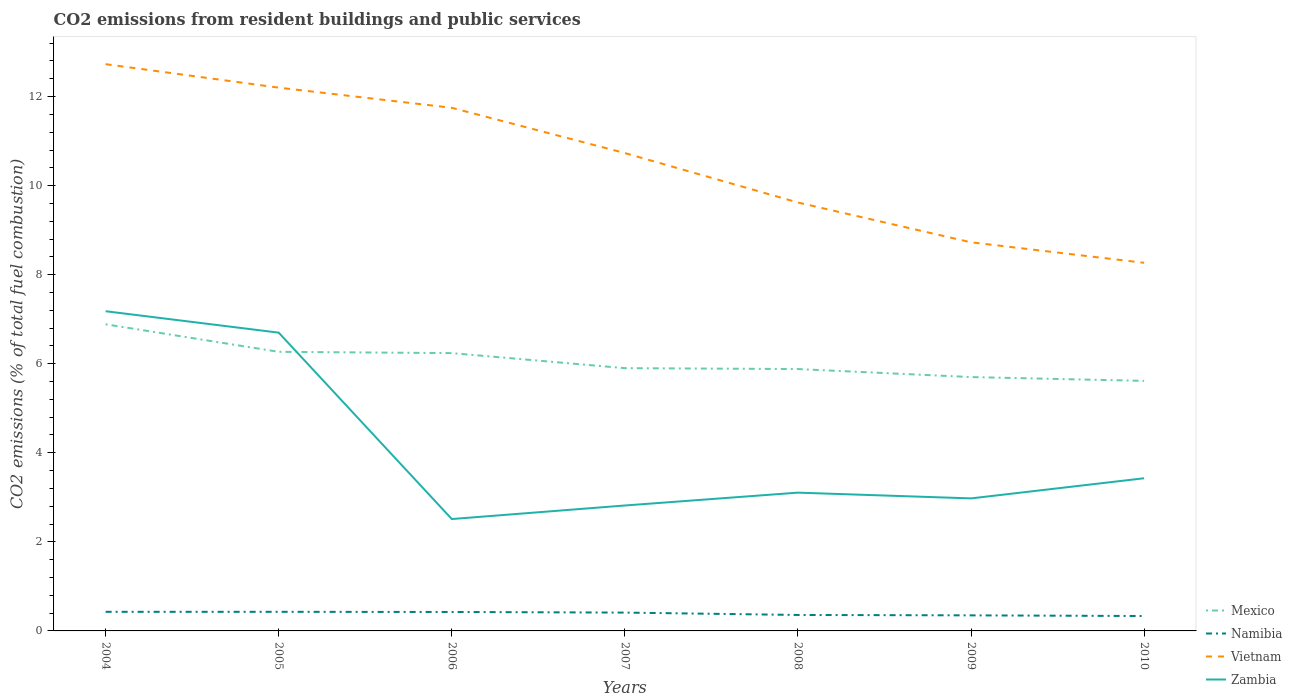Is the number of lines equal to the number of legend labels?
Provide a short and direct response. Yes. Across all years, what is the maximum total CO2 emitted in Zambia?
Offer a terse response. 2.51. In which year was the total CO2 emitted in Zambia maximum?
Provide a short and direct response. 2006. What is the total total CO2 emitted in Namibia in the graph?
Your answer should be compact. 0.05. What is the difference between the highest and the second highest total CO2 emitted in Namibia?
Provide a short and direct response. 0.09. Is the total CO2 emitted in Mexico strictly greater than the total CO2 emitted in Namibia over the years?
Your answer should be compact. No. How many years are there in the graph?
Provide a short and direct response. 7. What is the difference between two consecutive major ticks on the Y-axis?
Your answer should be compact. 2. Are the values on the major ticks of Y-axis written in scientific E-notation?
Give a very brief answer. No. Does the graph contain any zero values?
Provide a short and direct response. No. Does the graph contain grids?
Your answer should be compact. No. Where does the legend appear in the graph?
Offer a very short reply. Bottom right. What is the title of the graph?
Provide a succinct answer. CO2 emissions from resident buildings and public services. What is the label or title of the Y-axis?
Offer a terse response. CO2 emissions (% of total fuel combustion). What is the CO2 emissions (% of total fuel combustion) in Mexico in 2004?
Ensure brevity in your answer.  6.89. What is the CO2 emissions (% of total fuel combustion) in Namibia in 2004?
Give a very brief answer. 0.43. What is the CO2 emissions (% of total fuel combustion) of Vietnam in 2004?
Provide a short and direct response. 12.73. What is the CO2 emissions (% of total fuel combustion) in Zambia in 2004?
Your answer should be very brief. 7.18. What is the CO2 emissions (% of total fuel combustion) of Mexico in 2005?
Your answer should be compact. 6.27. What is the CO2 emissions (% of total fuel combustion) in Namibia in 2005?
Ensure brevity in your answer.  0.43. What is the CO2 emissions (% of total fuel combustion) in Vietnam in 2005?
Your response must be concise. 12.2. What is the CO2 emissions (% of total fuel combustion) of Zambia in 2005?
Keep it short and to the point. 6.7. What is the CO2 emissions (% of total fuel combustion) of Mexico in 2006?
Your answer should be compact. 6.24. What is the CO2 emissions (% of total fuel combustion) of Namibia in 2006?
Give a very brief answer. 0.43. What is the CO2 emissions (% of total fuel combustion) in Vietnam in 2006?
Provide a succinct answer. 11.75. What is the CO2 emissions (% of total fuel combustion) of Zambia in 2006?
Offer a very short reply. 2.51. What is the CO2 emissions (% of total fuel combustion) in Mexico in 2007?
Your response must be concise. 5.9. What is the CO2 emissions (% of total fuel combustion) in Namibia in 2007?
Provide a short and direct response. 0.41. What is the CO2 emissions (% of total fuel combustion) in Vietnam in 2007?
Give a very brief answer. 10.73. What is the CO2 emissions (% of total fuel combustion) of Zambia in 2007?
Ensure brevity in your answer.  2.82. What is the CO2 emissions (% of total fuel combustion) in Mexico in 2008?
Provide a short and direct response. 5.88. What is the CO2 emissions (% of total fuel combustion) of Namibia in 2008?
Your answer should be compact. 0.36. What is the CO2 emissions (% of total fuel combustion) in Vietnam in 2008?
Keep it short and to the point. 9.62. What is the CO2 emissions (% of total fuel combustion) in Zambia in 2008?
Keep it short and to the point. 3.11. What is the CO2 emissions (% of total fuel combustion) in Mexico in 2009?
Give a very brief answer. 5.7. What is the CO2 emissions (% of total fuel combustion) in Namibia in 2009?
Provide a short and direct response. 0.35. What is the CO2 emissions (% of total fuel combustion) in Vietnam in 2009?
Ensure brevity in your answer.  8.73. What is the CO2 emissions (% of total fuel combustion) in Zambia in 2009?
Offer a terse response. 2.98. What is the CO2 emissions (% of total fuel combustion) in Mexico in 2010?
Provide a short and direct response. 5.62. What is the CO2 emissions (% of total fuel combustion) of Namibia in 2010?
Offer a very short reply. 0.33. What is the CO2 emissions (% of total fuel combustion) in Vietnam in 2010?
Your answer should be very brief. 8.27. What is the CO2 emissions (% of total fuel combustion) in Zambia in 2010?
Keep it short and to the point. 3.43. Across all years, what is the maximum CO2 emissions (% of total fuel combustion) of Mexico?
Your answer should be compact. 6.89. Across all years, what is the maximum CO2 emissions (% of total fuel combustion) of Namibia?
Give a very brief answer. 0.43. Across all years, what is the maximum CO2 emissions (% of total fuel combustion) of Vietnam?
Offer a terse response. 12.73. Across all years, what is the maximum CO2 emissions (% of total fuel combustion) of Zambia?
Offer a terse response. 7.18. Across all years, what is the minimum CO2 emissions (% of total fuel combustion) in Mexico?
Keep it short and to the point. 5.62. Across all years, what is the minimum CO2 emissions (% of total fuel combustion) of Namibia?
Make the answer very short. 0.33. Across all years, what is the minimum CO2 emissions (% of total fuel combustion) of Vietnam?
Provide a succinct answer. 8.27. Across all years, what is the minimum CO2 emissions (% of total fuel combustion) of Zambia?
Offer a very short reply. 2.51. What is the total CO2 emissions (% of total fuel combustion) of Mexico in the graph?
Offer a terse response. 42.49. What is the total CO2 emissions (% of total fuel combustion) of Namibia in the graph?
Provide a short and direct response. 2.74. What is the total CO2 emissions (% of total fuel combustion) in Vietnam in the graph?
Give a very brief answer. 74.02. What is the total CO2 emissions (% of total fuel combustion) in Zambia in the graph?
Your response must be concise. 28.72. What is the difference between the CO2 emissions (% of total fuel combustion) in Mexico in 2004 and that in 2005?
Your answer should be very brief. 0.62. What is the difference between the CO2 emissions (% of total fuel combustion) in Vietnam in 2004 and that in 2005?
Offer a terse response. 0.53. What is the difference between the CO2 emissions (% of total fuel combustion) in Zambia in 2004 and that in 2005?
Provide a short and direct response. 0.48. What is the difference between the CO2 emissions (% of total fuel combustion) in Mexico in 2004 and that in 2006?
Offer a terse response. 0.65. What is the difference between the CO2 emissions (% of total fuel combustion) of Namibia in 2004 and that in 2006?
Your answer should be compact. 0. What is the difference between the CO2 emissions (% of total fuel combustion) in Vietnam in 2004 and that in 2006?
Ensure brevity in your answer.  0.98. What is the difference between the CO2 emissions (% of total fuel combustion) of Zambia in 2004 and that in 2006?
Provide a short and direct response. 4.67. What is the difference between the CO2 emissions (% of total fuel combustion) of Mexico in 2004 and that in 2007?
Provide a succinct answer. 0.99. What is the difference between the CO2 emissions (% of total fuel combustion) in Namibia in 2004 and that in 2007?
Your response must be concise. 0.02. What is the difference between the CO2 emissions (% of total fuel combustion) in Vietnam in 2004 and that in 2007?
Your response must be concise. 2. What is the difference between the CO2 emissions (% of total fuel combustion) of Zambia in 2004 and that in 2007?
Make the answer very short. 4.36. What is the difference between the CO2 emissions (% of total fuel combustion) in Mexico in 2004 and that in 2008?
Provide a succinct answer. 1.01. What is the difference between the CO2 emissions (% of total fuel combustion) in Namibia in 2004 and that in 2008?
Ensure brevity in your answer.  0.07. What is the difference between the CO2 emissions (% of total fuel combustion) of Vietnam in 2004 and that in 2008?
Offer a very short reply. 3.11. What is the difference between the CO2 emissions (% of total fuel combustion) of Zambia in 2004 and that in 2008?
Make the answer very short. 4.07. What is the difference between the CO2 emissions (% of total fuel combustion) of Mexico in 2004 and that in 2009?
Ensure brevity in your answer.  1.19. What is the difference between the CO2 emissions (% of total fuel combustion) in Namibia in 2004 and that in 2009?
Provide a short and direct response. 0.08. What is the difference between the CO2 emissions (% of total fuel combustion) of Vietnam in 2004 and that in 2009?
Ensure brevity in your answer.  4. What is the difference between the CO2 emissions (% of total fuel combustion) of Zambia in 2004 and that in 2009?
Offer a very short reply. 4.2. What is the difference between the CO2 emissions (% of total fuel combustion) of Mexico in 2004 and that in 2010?
Offer a terse response. 1.27. What is the difference between the CO2 emissions (% of total fuel combustion) in Namibia in 2004 and that in 2010?
Provide a short and direct response. 0.09. What is the difference between the CO2 emissions (% of total fuel combustion) in Vietnam in 2004 and that in 2010?
Your response must be concise. 4.46. What is the difference between the CO2 emissions (% of total fuel combustion) of Zambia in 2004 and that in 2010?
Give a very brief answer. 3.75. What is the difference between the CO2 emissions (% of total fuel combustion) in Mexico in 2005 and that in 2006?
Provide a succinct answer. 0.03. What is the difference between the CO2 emissions (% of total fuel combustion) of Namibia in 2005 and that in 2006?
Ensure brevity in your answer.  0. What is the difference between the CO2 emissions (% of total fuel combustion) of Vietnam in 2005 and that in 2006?
Keep it short and to the point. 0.45. What is the difference between the CO2 emissions (% of total fuel combustion) in Zambia in 2005 and that in 2006?
Offer a very short reply. 4.19. What is the difference between the CO2 emissions (% of total fuel combustion) of Mexico in 2005 and that in 2007?
Your response must be concise. 0.37. What is the difference between the CO2 emissions (% of total fuel combustion) in Namibia in 2005 and that in 2007?
Provide a short and direct response. 0.02. What is the difference between the CO2 emissions (% of total fuel combustion) in Vietnam in 2005 and that in 2007?
Provide a succinct answer. 1.47. What is the difference between the CO2 emissions (% of total fuel combustion) in Zambia in 2005 and that in 2007?
Offer a terse response. 3.88. What is the difference between the CO2 emissions (% of total fuel combustion) of Mexico in 2005 and that in 2008?
Your response must be concise. 0.39. What is the difference between the CO2 emissions (% of total fuel combustion) in Namibia in 2005 and that in 2008?
Provide a short and direct response. 0.07. What is the difference between the CO2 emissions (% of total fuel combustion) in Vietnam in 2005 and that in 2008?
Ensure brevity in your answer.  2.58. What is the difference between the CO2 emissions (% of total fuel combustion) of Zambia in 2005 and that in 2008?
Provide a short and direct response. 3.59. What is the difference between the CO2 emissions (% of total fuel combustion) of Mexico in 2005 and that in 2009?
Your answer should be compact. 0.57. What is the difference between the CO2 emissions (% of total fuel combustion) of Namibia in 2005 and that in 2009?
Your answer should be compact. 0.08. What is the difference between the CO2 emissions (% of total fuel combustion) in Vietnam in 2005 and that in 2009?
Your response must be concise. 3.47. What is the difference between the CO2 emissions (% of total fuel combustion) of Zambia in 2005 and that in 2009?
Offer a very short reply. 3.72. What is the difference between the CO2 emissions (% of total fuel combustion) in Mexico in 2005 and that in 2010?
Give a very brief answer. 0.65. What is the difference between the CO2 emissions (% of total fuel combustion) in Namibia in 2005 and that in 2010?
Offer a very short reply. 0.09. What is the difference between the CO2 emissions (% of total fuel combustion) in Vietnam in 2005 and that in 2010?
Keep it short and to the point. 3.93. What is the difference between the CO2 emissions (% of total fuel combustion) in Zambia in 2005 and that in 2010?
Ensure brevity in your answer.  3.27. What is the difference between the CO2 emissions (% of total fuel combustion) in Mexico in 2006 and that in 2007?
Provide a short and direct response. 0.34. What is the difference between the CO2 emissions (% of total fuel combustion) in Namibia in 2006 and that in 2007?
Keep it short and to the point. 0.01. What is the difference between the CO2 emissions (% of total fuel combustion) in Vietnam in 2006 and that in 2007?
Offer a terse response. 1.02. What is the difference between the CO2 emissions (% of total fuel combustion) of Zambia in 2006 and that in 2007?
Keep it short and to the point. -0.3. What is the difference between the CO2 emissions (% of total fuel combustion) of Mexico in 2006 and that in 2008?
Your answer should be very brief. 0.36. What is the difference between the CO2 emissions (% of total fuel combustion) of Namibia in 2006 and that in 2008?
Your response must be concise. 0.07. What is the difference between the CO2 emissions (% of total fuel combustion) in Vietnam in 2006 and that in 2008?
Your response must be concise. 2.13. What is the difference between the CO2 emissions (% of total fuel combustion) of Zambia in 2006 and that in 2008?
Your answer should be very brief. -0.59. What is the difference between the CO2 emissions (% of total fuel combustion) of Mexico in 2006 and that in 2009?
Offer a very short reply. 0.54. What is the difference between the CO2 emissions (% of total fuel combustion) of Namibia in 2006 and that in 2009?
Make the answer very short. 0.08. What is the difference between the CO2 emissions (% of total fuel combustion) of Vietnam in 2006 and that in 2009?
Offer a terse response. 3.02. What is the difference between the CO2 emissions (% of total fuel combustion) in Zambia in 2006 and that in 2009?
Ensure brevity in your answer.  -0.46. What is the difference between the CO2 emissions (% of total fuel combustion) in Mexico in 2006 and that in 2010?
Offer a very short reply. 0.62. What is the difference between the CO2 emissions (% of total fuel combustion) of Namibia in 2006 and that in 2010?
Provide a short and direct response. 0.09. What is the difference between the CO2 emissions (% of total fuel combustion) in Vietnam in 2006 and that in 2010?
Offer a terse response. 3.48. What is the difference between the CO2 emissions (% of total fuel combustion) in Zambia in 2006 and that in 2010?
Provide a short and direct response. -0.92. What is the difference between the CO2 emissions (% of total fuel combustion) of Mexico in 2007 and that in 2008?
Provide a succinct answer. 0.02. What is the difference between the CO2 emissions (% of total fuel combustion) of Namibia in 2007 and that in 2008?
Give a very brief answer. 0.05. What is the difference between the CO2 emissions (% of total fuel combustion) in Vietnam in 2007 and that in 2008?
Your response must be concise. 1.11. What is the difference between the CO2 emissions (% of total fuel combustion) in Zambia in 2007 and that in 2008?
Provide a succinct answer. -0.29. What is the difference between the CO2 emissions (% of total fuel combustion) in Mexico in 2007 and that in 2009?
Offer a very short reply. 0.2. What is the difference between the CO2 emissions (% of total fuel combustion) in Namibia in 2007 and that in 2009?
Provide a short and direct response. 0.06. What is the difference between the CO2 emissions (% of total fuel combustion) of Vietnam in 2007 and that in 2009?
Ensure brevity in your answer.  2. What is the difference between the CO2 emissions (% of total fuel combustion) of Zambia in 2007 and that in 2009?
Provide a succinct answer. -0.16. What is the difference between the CO2 emissions (% of total fuel combustion) of Mexico in 2007 and that in 2010?
Offer a terse response. 0.29. What is the difference between the CO2 emissions (% of total fuel combustion) in Namibia in 2007 and that in 2010?
Your answer should be very brief. 0.08. What is the difference between the CO2 emissions (% of total fuel combustion) in Vietnam in 2007 and that in 2010?
Offer a terse response. 2.46. What is the difference between the CO2 emissions (% of total fuel combustion) in Zambia in 2007 and that in 2010?
Make the answer very short. -0.61. What is the difference between the CO2 emissions (% of total fuel combustion) of Mexico in 2008 and that in 2009?
Make the answer very short. 0.18. What is the difference between the CO2 emissions (% of total fuel combustion) in Namibia in 2008 and that in 2009?
Offer a terse response. 0.01. What is the difference between the CO2 emissions (% of total fuel combustion) in Vietnam in 2008 and that in 2009?
Offer a very short reply. 0.89. What is the difference between the CO2 emissions (% of total fuel combustion) in Zambia in 2008 and that in 2009?
Your response must be concise. 0.13. What is the difference between the CO2 emissions (% of total fuel combustion) of Mexico in 2008 and that in 2010?
Your answer should be very brief. 0.27. What is the difference between the CO2 emissions (% of total fuel combustion) in Namibia in 2008 and that in 2010?
Offer a very short reply. 0.02. What is the difference between the CO2 emissions (% of total fuel combustion) of Vietnam in 2008 and that in 2010?
Keep it short and to the point. 1.35. What is the difference between the CO2 emissions (% of total fuel combustion) in Zambia in 2008 and that in 2010?
Give a very brief answer. -0.32. What is the difference between the CO2 emissions (% of total fuel combustion) of Mexico in 2009 and that in 2010?
Provide a succinct answer. 0.09. What is the difference between the CO2 emissions (% of total fuel combustion) of Namibia in 2009 and that in 2010?
Provide a short and direct response. 0.02. What is the difference between the CO2 emissions (% of total fuel combustion) of Vietnam in 2009 and that in 2010?
Offer a terse response. 0.46. What is the difference between the CO2 emissions (% of total fuel combustion) of Zambia in 2009 and that in 2010?
Offer a terse response. -0.45. What is the difference between the CO2 emissions (% of total fuel combustion) of Mexico in 2004 and the CO2 emissions (% of total fuel combustion) of Namibia in 2005?
Provide a succinct answer. 6.46. What is the difference between the CO2 emissions (% of total fuel combustion) in Mexico in 2004 and the CO2 emissions (% of total fuel combustion) in Vietnam in 2005?
Offer a very short reply. -5.31. What is the difference between the CO2 emissions (% of total fuel combustion) in Mexico in 2004 and the CO2 emissions (% of total fuel combustion) in Zambia in 2005?
Ensure brevity in your answer.  0.19. What is the difference between the CO2 emissions (% of total fuel combustion) of Namibia in 2004 and the CO2 emissions (% of total fuel combustion) of Vietnam in 2005?
Provide a short and direct response. -11.77. What is the difference between the CO2 emissions (% of total fuel combustion) of Namibia in 2004 and the CO2 emissions (% of total fuel combustion) of Zambia in 2005?
Ensure brevity in your answer.  -6.27. What is the difference between the CO2 emissions (% of total fuel combustion) of Vietnam in 2004 and the CO2 emissions (% of total fuel combustion) of Zambia in 2005?
Provide a short and direct response. 6.03. What is the difference between the CO2 emissions (% of total fuel combustion) in Mexico in 2004 and the CO2 emissions (% of total fuel combustion) in Namibia in 2006?
Keep it short and to the point. 6.46. What is the difference between the CO2 emissions (% of total fuel combustion) of Mexico in 2004 and the CO2 emissions (% of total fuel combustion) of Vietnam in 2006?
Your answer should be very brief. -4.86. What is the difference between the CO2 emissions (% of total fuel combustion) of Mexico in 2004 and the CO2 emissions (% of total fuel combustion) of Zambia in 2006?
Offer a very short reply. 4.37. What is the difference between the CO2 emissions (% of total fuel combustion) of Namibia in 2004 and the CO2 emissions (% of total fuel combustion) of Vietnam in 2006?
Provide a succinct answer. -11.32. What is the difference between the CO2 emissions (% of total fuel combustion) in Namibia in 2004 and the CO2 emissions (% of total fuel combustion) in Zambia in 2006?
Provide a succinct answer. -2.08. What is the difference between the CO2 emissions (% of total fuel combustion) in Vietnam in 2004 and the CO2 emissions (% of total fuel combustion) in Zambia in 2006?
Give a very brief answer. 10.22. What is the difference between the CO2 emissions (% of total fuel combustion) of Mexico in 2004 and the CO2 emissions (% of total fuel combustion) of Namibia in 2007?
Offer a terse response. 6.47. What is the difference between the CO2 emissions (% of total fuel combustion) in Mexico in 2004 and the CO2 emissions (% of total fuel combustion) in Vietnam in 2007?
Ensure brevity in your answer.  -3.85. What is the difference between the CO2 emissions (% of total fuel combustion) of Mexico in 2004 and the CO2 emissions (% of total fuel combustion) of Zambia in 2007?
Provide a short and direct response. 4.07. What is the difference between the CO2 emissions (% of total fuel combustion) of Namibia in 2004 and the CO2 emissions (% of total fuel combustion) of Vietnam in 2007?
Your answer should be very brief. -10.3. What is the difference between the CO2 emissions (% of total fuel combustion) in Namibia in 2004 and the CO2 emissions (% of total fuel combustion) in Zambia in 2007?
Ensure brevity in your answer.  -2.39. What is the difference between the CO2 emissions (% of total fuel combustion) of Vietnam in 2004 and the CO2 emissions (% of total fuel combustion) of Zambia in 2007?
Your answer should be compact. 9.91. What is the difference between the CO2 emissions (% of total fuel combustion) in Mexico in 2004 and the CO2 emissions (% of total fuel combustion) in Namibia in 2008?
Give a very brief answer. 6.53. What is the difference between the CO2 emissions (% of total fuel combustion) in Mexico in 2004 and the CO2 emissions (% of total fuel combustion) in Vietnam in 2008?
Your answer should be very brief. -2.73. What is the difference between the CO2 emissions (% of total fuel combustion) in Mexico in 2004 and the CO2 emissions (% of total fuel combustion) in Zambia in 2008?
Keep it short and to the point. 3.78. What is the difference between the CO2 emissions (% of total fuel combustion) in Namibia in 2004 and the CO2 emissions (% of total fuel combustion) in Vietnam in 2008?
Your answer should be compact. -9.19. What is the difference between the CO2 emissions (% of total fuel combustion) in Namibia in 2004 and the CO2 emissions (% of total fuel combustion) in Zambia in 2008?
Keep it short and to the point. -2.68. What is the difference between the CO2 emissions (% of total fuel combustion) of Vietnam in 2004 and the CO2 emissions (% of total fuel combustion) of Zambia in 2008?
Ensure brevity in your answer.  9.62. What is the difference between the CO2 emissions (% of total fuel combustion) of Mexico in 2004 and the CO2 emissions (% of total fuel combustion) of Namibia in 2009?
Keep it short and to the point. 6.54. What is the difference between the CO2 emissions (% of total fuel combustion) in Mexico in 2004 and the CO2 emissions (% of total fuel combustion) in Vietnam in 2009?
Your response must be concise. -1.84. What is the difference between the CO2 emissions (% of total fuel combustion) of Mexico in 2004 and the CO2 emissions (% of total fuel combustion) of Zambia in 2009?
Make the answer very short. 3.91. What is the difference between the CO2 emissions (% of total fuel combustion) of Namibia in 2004 and the CO2 emissions (% of total fuel combustion) of Vietnam in 2009?
Offer a terse response. -8.3. What is the difference between the CO2 emissions (% of total fuel combustion) in Namibia in 2004 and the CO2 emissions (% of total fuel combustion) in Zambia in 2009?
Offer a terse response. -2.55. What is the difference between the CO2 emissions (% of total fuel combustion) in Vietnam in 2004 and the CO2 emissions (% of total fuel combustion) in Zambia in 2009?
Provide a succinct answer. 9.75. What is the difference between the CO2 emissions (% of total fuel combustion) of Mexico in 2004 and the CO2 emissions (% of total fuel combustion) of Namibia in 2010?
Offer a very short reply. 6.55. What is the difference between the CO2 emissions (% of total fuel combustion) in Mexico in 2004 and the CO2 emissions (% of total fuel combustion) in Vietnam in 2010?
Provide a short and direct response. -1.38. What is the difference between the CO2 emissions (% of total fuel combustion) of Mexico in 2004 and the CO2 emissions (% of total fuel combustion) of Zambia in 2010?
Your answer should be compact. 3.46. What is the difference between the CO2 emissions (% of total fuel combustion) in Namibia in 2004 and the CO2 emissions (% of total fuel combustion) in Vietnam in 2010?
Your answer should be very brief. -7.84. What is the difference between the CO2 emissions (% of total fuel combustion) of Namibia in 2004 and the CO2 emissions (% of total fuel combustion) of Zambia in 2010?
Offer a terse response. -3. What is the difference between the CO2 emissions (% of total fuel combustion) of Vietnam in 2004 and the CO2 emissions (% of total fuel combustion) of Zambia in 2010?
Your answer should be very brief. 9.3. What is the difference between the CO2 emissions (% of total fuel combustion) of Mexico in 2005 and the CO2 emissions (% of total fuel combustion) of Namibia in 2006?
Your response must be concise. 5.84. What is the difference between the CO2 emissions (% of total fuel combustion) of Mexico in 2005 and the CO2 emissions (% of total fuel combustion) of Vietnam in 2006?
Offer a terse response. -5.48. What is the difference between the CO2 emissions (% of total fuel combustion) of Mexico in 2005 and the CO2 emissions (% of total fuel combustion) of Zambia in 2006?
Your response must be concise. 3.76. What is the difference between the CO2 emissions (% of total fuel combustion) of Namibia in 2005 and the CO2 emissions (% of total fuel combustion) of Vietnam in 2006?
Offer a terse response. -11.32. What is the difference between the CO2 emissions (% of total fuel combustion) of Namibia in 2005 and the CO2 emissions (% of total fuel combustion) of Zambia in 2006?
Offer a very short reply. -2.08. What is the difference between the CO2 emissions (% of total fuel combustion) in Vietnam in 2005 and the CO2 emissions (% of total fuel combustion) in Zambia in 2006?
Your answer should be very brief. 9.69. What is the difference between the CO2 emissions (% of total fuel combustion) in Mexico in 2005 and the CO2 emissions (% of total fuel combustion) in Namibia in 2007?
Offer a very short reply. 5.86. What is the difference between the CO2 emissions (% of total fuel combustion) in Mexico in 2005 and the CO2 emissions (% of total fuel combustion) in Vietnam in 2007?
Make the answer very short. -4.46. What is the difference between the CO2 emissions (% of total fuel combustion) in Mexico in 2005 and the CO2 emissions (% of total fuel combustion) in Zambia in 2007?
Provide a succinct answer. 3.45. What is the difference between the CO2 emissions (% of total fuel combustion) in Namibia in 2005 and the CO2 emissions (% of total fuel combustion) in Vietnam in 2007?
Ensure brevity in your answer.  -10.3. What is the difference between the CO2 emissions (% of total fuel combustion) in Namibia in 2005 and the CO2 emissions (% of total fuel combustion) in Zambia in 2007?
Keep it short and to the point. -2.39. What is the difference between the CO2 emissions (% of total fuel combustion) of Vietnam in 2005 and the CO2 emissions (% of total fuel combustion) of Zambia in 2007?
Make the answer very short. 9.38. What is the difference between the CO2 emissions (% of total fuel combustion) of Mexico in 2005 and the CO2 emissions (% of total fuel combustion) of Namibia in 2008?
Make the answer very short. 5.91. What is the difference between the CO2 emissions (% of total fuel combustion) of Mexico in 2005 and the CO2 emissions (% of total fuel combustion) of Vietnam in 2008?
Make the answer very short. -3.35. What is the difference between the CO2 emissions (% of total fuel combustion) of Mexico in 2005 and the CO2 emissions (% of total fuel combustion) of Zambia in 2008?
Your answer should be compact. 3.16. What is the difference between the CO2 emissions (% of total fuel combustion) in Namibia in 2005 and the CO2 emissions (% of total fuel combustion) in Vietnam in 2008?
Keep it short and to the point. -9.19. What is the difference between the CO2 emissions (% of total fuel combustion) of Namibia in 2005 and the CO2 emissions (% of total fuel combustion) of Zambia in 2008?
Offer a very short reply. -2.68. What is the difference between the CO2 emissions (% of total fuel combustion) of Vietnam in 2005 and the CO2 emissions (% of total fuel combustion) of Zambia in 2008?
Your answer should be compact. 9.1. What is the difference between the CO2 emissions (% of total fuel combustion) of Mexico in 2005 and the CO2 emissions (% of total fuel combustion) of Namibia in 2009?
Give a very brief answer. 5.92. What is the difference between the CO2 emissions (% of total fuel combustion) of Mexico in 2005 and the CO2 emissions (% of total fuel combustion) of Vietnam in 2009?
Your answer should be compact. -2.46. What is the difference between the CO2 emissions (% of total fuel combustion) in Mexico in 2005 and the CO2 emissions (% of total fuel combustion) in Zambia in 2009?
Your response must be concise. 3.29. What is the difference between the CO2 emissions (% of total fuel combustion) of Namibia in 2005 and the CO2 emissions (% of total fuel combustion) of Vietnam in 2009?
Your response must be concise. -8.3. What is the difference between the CO2 emissions (% of total fuel combustion) in Namibia in 2005 and the CO2 emissions (% of total fuel combustion) in Zambia in 2009?
Your answer should be compact. -2.55. What is the difference between the CO2 emissions (% of total fuel combustion) in Vietnam in 2005 and the CO2 emissions (% of total fuel combustion) in Zambia in 2009?
Provide a succinct answer. 9.22. What is the difference between the CO2 emissions (% of total fuel combustion) in Mexico in 2005 and the CO2 emissions (% of total fuel combustion) in Namibia in 2010?
Make the answer very short. 5.93. What is the difference between the CO2 emissions (% of total fuel combustion) in Mexico in 2005 and the CO2 emissions (% of total fuel combustion) in Vietnam in 2010?
Make the answer very short. -2. What is the difference between the CO2 emissions (% of total fuel combustion) in Mexico in 2005 and the CO2 emissions (% of total fuel combustion) in Zambia in 2010?
Give a very brief answer. 2.84. What is the difference between the CO2 emissions (% of total fuel combustion) of Namibia in 2005 and the CO2 emissions (% of total fuel combustion) of Vietnam in 2010?
Ensure brevity in your answer.  -7.84. What is the difference between the CO2 emissions (% of total fuel combustion) in Namibia in 2005 and the CO2 emissions (% of total fuel combustion) in Zambia in 2010?
Provide a short and direct response. -3. What is the difference between the CO2 emissions (% of total fuel combustion) in Vietnam in 2005 and the CO2 emissions (% of total fuel combustion) in Zambia in 2010?
Keep it short and to the point. 8.77. What is the difference between the CO2 emissions (% of total fuel combustion) in Mexico in 2006 and the CO2 emissions (% of total fuel combustion) in Namibia in 2007?
Your answer should be compact. 5.83. What is the difference between the CO2 emissions (% of total fuel combustion) in Mexico in 2006 and the CO2 emissions (% of total fuel combustion) in Vietnam in 2007?
Keep it short and to the point. -4.49. What is the difference between the CO2 emissions (% of total fuel combustion) in Mexico in 2006 and the CO2 emissions (% of total fuel combustion) in Zambia in 2007?
Offer a terse response. 3.42. What is the difference between the CO2 emissions (% of total fuel combustion) of Namibia in 2006 and the CO2 emissions (% of total fuel combustion) of Vietnam in 2007?
Provide a succinct answer. -10.31. What is the difference between the CO2 emissions (% of total fuel combustion) in Namibia in 2006 and the CO2 emissions (% of total fuel combustion) in Zambia in 2007?
Make the answer very short. -2.39. What is the difference between the CO2 emissions (% of total fuel combustion) in Vietnam in 2006 and the CO2 emissions (% of total fuel combustion) in Zambia in 2007?
Give a very brief answer. 8.93. What is the difference between the CO2 emissions (% of total fuel combustion) in Mexico in 2006 and the CO2 emissions (% of total fuel combustion) in Namibia in 2008?
Give a very brief answer. 5.88. What is the difference between the CO2 emissions (% of total fuel combustion) in Mexico in 2006 and the CO2 emissions (% of total fuel combustion) in Vietnam in 2008?
Your answer should be compact. -3.38. What is the difference between the CO2 emissions (% of total fuel combustion) of Mexico in 2006 and the CO2 emissions (% of total fuel combustion) of Zambia in 2008?
Offer a very short reply. 3.13. What is the difference between the CO2 emissions (% of total fuel combustion) of Namibia in 2006 and the CO2 emissions (% of total fuel combustion) of Vietnam in 2008?
Your answer should be very brief. -9.2. What is the difference between the CO2 emissions (% of total fuel combustion) of Namibia in 2006 and the CO2 emissions (% of total fuel combustion) of Zambia in 2008?
Offer a very short reply. -2.68. What is the difference between the CO2 emissions (% of total fuel combustion) in Vietnam in 2006 and the CO2 emissions (% of total fuel combustion) in Zambia in 2008?
Keep it short and to the point. 8.64. What is the difference between the CO2 emissions (% of total fuel combustion) of Mexico in 2006 and the CO2 emissions (% of total fuel combustion) of Namibia in 2009?
Keep it short and to the point. 5.89. What is the difference between the CO2 emissions (% of total fuel combustion) in Mexico in 2006 and the CO2 emissions (% of total fuel combustion) in Vietnam in 2009?
Provide a short and direct response. -2.49. What is the difference between the CO2 emissions (% of total fuel combustion) of Mexico in 2006 and the CO2 emissions (% of total fuel combustion) of Zambia in 2009?
Ensure brevity in your answer.  3.26. What is the difference between the CO2 emissions (% of total fuel combustion) of Namibia in 2006 and the CO2 emissions (% of total fuel combustion) of Vietnam in 2009?
Offer a very short reply. -8.3. What is the difference between the CO2 emissions (% of total fuel combustion) of Namibia in 2006 and the CO2 emissions (% of total fuel combustion) of Zambia in 2009?
Your answer should be very brief. -2.55. What is the difference between the CO2 emissions (% of total fuel combustion) of Vietnam in 2006 and the CO2 emissions (% of total fuel combustion) of Zambia in 2009?
Provide a short and direct response. 8.77. What is the difference between the CO2 emissions (% of total fuel combustion) of Mexico in 2006 and the CO2 emissions (% of total fuel combustion) of Namibia in 2010?
Your response must be concise. 5.9. What is the difference between the CO2 emissions (% of total fuel combustion) in Mexico in 2006 and the CO2 emissions (% of total fuel combustion) in Vietnam in 2010?
Provide a short and direct response. -2.03. What is the difference between the CO2 emissions (% of total fuel combustion) of Mexico in 2006 and the CO2 emissions (% of total fuel combustion) of Zambia in 2010?
Offer a terse response. 2.81. What is the difference between the CO2 emissions (% of total fuel combustion) of Namibia in 2006 and the CO2 emissions (% of total fuel combustion) of Vietnam in 2010?
Keep it short and to the point. -7.84. What is the difference between the CO2 emissions (% of total fuel combustion) in Namibia in 2006 and the CO2 emissions (% of total fuel combustion) in Zambia in 2010?
Offer a terse response. -3. What is the difference between the CO2 emissions (% of total fuel combustion) in Vietnam in 2006 and the CO2 emissions (% of total fuel combustion) in Zambia in 2010?
Provide a succinct answer. 8.32. What is the difference between the CO2 emissions (% of total fuel combustion) in Mexico in 2007 and the CO2 emissions (% of total fuel combustion) in Namibia in 2008?
Provide a succinct answer. 5.54. What is the difference between the CO2 emissions (% of total fuel combustion) of Mexico in 2007 and the CO2 emissions (% of total fuel combustion) of Vietnam in 2008?
Provide a succinct answer. -3.72. What is the difference between the CO2 emissions (% of total fuel combustion) of Mexico in 2007 and the CO2 emissions (% of total fuel combustion) of Zambia in 2008?
Your answer should be very brief. 2.8. What is the difference between the CO2 emissions (% of total fuel combustion) of Namibia in 2007 and the CO2 emissions (% of total fuel combustion) of Vietnam in 2008?
Your response must be concise. -9.21. What is the difference between the CO2 emissions (% of total fuel combustion) of Namibia in 2007 and the CO2 emissions (% of total fuel combustion) of Zambia in 2008?
Make the answer very short. -2.69. What is the difference between the CO2 emissions (% of total fuel combustion) of Vietnam in 2007 and the CO2 emissions (% of total fuel combustion) of Zambia in 2008?
Your answer should be very brief. 7.63. What is the difference between the CO2 emissions (% of total fuel combustion) of Mexico in 2007 and the CO2 emissions (% of total fuel combustion) of Namibia in 2009?
Your answer should be very brief. 5.55. What is the difference between the CO2 emissions (% of total fuel combustion) of Mexico in 2007 and the CO2 emissions (% of total fuel combustion) of Vietnam in 2009?
Provide a succinct answer. -2.83. What is the difference between the CO2 emissions (% of total fuel combustion) of Mexico in 2007 and the CO2 emissions (% of total fuel combustion) of Zambia in 2009?
Provide a short and direct response. 2.92. What is the difference between the CO2 emissions (% of total fuel combustion) in Namibia in 2007 and the CO2 emissions (% of total fuel combustion) in Vietnam in 2009?
Keep it short and to the point. -8.32. What is the difference between the CO2 emissions (% of total fuel combustion) in Namibia in 2007 and the CO2 emissions (% of total fuel combustion) in Zambia in 2009?
Provide a short and direct response. -2.56. What is the difference between the CO2 emissions (% of total fuel combustion) in Vietnam in 2007 and the CO2 emissions (% of total fuel combustion) in Zambia in 2009?
Your response must be concise. 7.76. What is the difference between the CO2 emissions (% of total fuel combustion) in Mexico in 2007 and the CO2 emissions (% of total fuel combustion) in Namibia in 2010?
Your response must be concise. 5.57. What is the difference between the CO2 emissions (% of total fuel combustion) in Mexico in 2007 and the CO2 emissions (% of total fuel combustion) in Vietnam in 2010?
Give a very brief answer. -2.37. What is the difference between the CO2 emissions (% of total fuel combustion) in Mexico in 2007 and the CO2 emissions (% of total fuel combustion) in Zambia in 2010?
Provide a short and direct response. 2.47. What is the difference between the CO2 emissions (% of total fuel combustion) of Namibia in 2007 and the CO2 emissions (% of total fuel combustion) of Vietnam in 2010?
Your answer should be very brief. -7.86. What is the difference between the CO2 emissions (% of total fuel combustion) in Namibia in 2007 and the CO2 emissions (% of total fuel combustion) in Zambia in 2010?
Offer a very short reply. -3.02. What is the difference between the CO2 emissions (% of total fuel combustion) in Vietnam in 2007 and the CO2 emissions (% of total fuel combustion) in Zambia in 2010?
Your answer should be very brief. 7.3. What is the difference between the CO2 emissions (% of total fuel combustion) in Mexico in 2008 and the CO2 emissions (% of total fuel combustion) in Namibia in 2009?
Keep it short and to the point. 5.53. What is the difference between the CO2 emissions (% of total fuel combustion) of Mexico in 2008 and the CO2 emissions (% of total fuel combustion) of Vietnam in 2009?
Give a very brief answer. -2.85. What is the difference between the CO2 emissions (% of total fuel combustion) of Mexico in 2008 and the CO2 emissions (% of total fuel combustion) of Zambia in 2009?
Provide a succinct answer. 2.9. What is the difference between the CO2 emissions (% of total fuel combustion) in Namibia in 2008 and the CO2 emissions (% of total fuel combustion) in Vietnam in 2009?
Make the answer very short. -8.37. What is the difference between the CO2 emissions (% of total fuel combustion) in Namibia in 2008 and the CO2 emissions (% of total fuel combustion) in Zambia in 2009?
Give a very brief answer. -2.62. What is the difference between the CO2 emissions (% of total fuel combustion) of Vietnam in 2008 and the CO2 emissions (% of total fuel combustion) of Zambia in 2009?
Your answer should be very brief. 6.64. What is the difference between the CO2 emissions (% of total fuel combustion) in Mexico in 2008 and the CO2 emissions (% of total fuel combustion) in Namibia in 2010?
Provide a succinct answer. 5.55. What is the difference between the CO2 emissions (% of total fuel combustion) in Mexico in 2008 and the CO2 emissions (% of total fuel combustion) in Vietnam in 2010?
Your answer should be compact. -2.39. What is the difference between the CO2 emissions (% of total fuel combustion) of Mexico in 2008 and the CO2 emissions (% of total fuel combustion) of Zambia in 2010?
Offer a very short reply. 2.45. What is the difference between the CO2 emissions (% of total fuel combustion) of Namibia in 2008 and the CO2 emissions (% of total fuel combustion) of Vietnam in 2010?
Offer a terse response. -7.91. What is the difference between the CO2 emissions (% of total fuel combustion) of Namibia in 2008 and the CO2 emissions (% of total fuel combustion) of Zambia in 2010?
Ensure brevity in your answer.  -3.07. What is the difference between the CO2 emissions (% of total fuel combustion) in Vietnam in 2008 and the CO2 emissions (% of total fuel combustion) in Zambia in 2010?
Give a very brief answer. 6.19. What is the difference between the CO2 emissions (% of total fuel combustion) of Mexico in 2009 and the CO2 emissions (% of total fuel combustion) of Namibia in 2010?
Offer a terse response. 5.37. What is the difference between the CO2 emissions (% of total fuel combustion) of Mexico in 2009 and the CO2 emissions (% of total fuel combustion) of Vietnam in 2010?
Your response must be concise. -2.57. What is the difference between the CO2 emissions (% of total fuel combustion) in Mexico in 2009 and the CO2 emissions (% of total fuel combustion) in Zambia in 2010?
Your answer should be very brief. 2.27. What is the difference between the CO2 emissions (% of total fuel combustion) in Namibia in 2009 and the CO2 emissions (% of total fuel combustion) in Vietnam in 2010?
Offer a very short reply. -7.92. What is the difference between the CO2 emissions (% of total fuel combustion) in Namibia in 2009 and the CO2 emissions (% of total fuel combustion) in Zambia in 2010?
Ensure brevity in your answer.  -3.08. What is the difference between the CO2 emissions (% of total fuel combustion) of Vietnam in 2009 and the CO2 emissions (% of total fuel combustion) of Zambia in 2010?
Your answer should be very brief. 5.3. What is the average CO2 emissions (% of total fuel combustion) in Mexico per year?
Provide a short and direct response. 6.07. What is the average CO2 emissions (% of total fuel combustion) of Namibia per year?
Provide a short and direct response. 0.39. What is the average CO2 emissions (% of total fuel combustion) of Vietnam per year?
Your response must be concise. 10.57. What is the average CO2 emissions (% of total fuel combustion) in Zambia per year?
Ensure brevity in your answer.  4.1. In the year 2004, what is the difference between the CO2 emissions (% of total fuel combustion) in Mexico and CO2 emissions (% of total fuel combustion) in Namibia?
Your answer should be compact. 6.46. In the year 2004, what is the difference between the CO2 emissions (% of total fuel combustion) in Mexico and CO2 emissions (% of total fuel combustion) in Vietnam?
Your response must be concise. -5.84. In the year 2004, what is the difference between the CO2 emissions (% of total fuel combustion) of Mexico and CO2 emissions (% of total fuel combustion) of Zambia?
Keep it short and to the point. -0.29. In the year 2004, what is the difference between the CO2 emissions (% of total fuel combustion) in Namibia and CO2 emissions (% of total fuel combustion) in Vietnam?
Provide a short and direct response. -12.3. In the year 2004, what is the difference between the CO2 emissions (% of total fuel combustion) in Namibia and CO2 emissions (% of total fuel combustion) in Zambia?
Ensure brevity in your answer.  -6.75. In the year 2004, what is the difference between the CO2 emissions (% of total fuel combustion) of Vietnam and CO2 emissions (% of total fuel combustion) of Zambia?
Your response must be concise. 5.55. In the year 2005, what is the difference between the CO2 emissions (% of total fuel combustion) of Mexico and CO2 emissions (% of total fuel combustion) of Namibia?
Provide a short and direct response. 5.84. In the year 2005, what is the difference between the CO2 emissions (% of total fuel combustion) in Mexico and CO2 emissions (% of total fuel combustion) in Vietnam?
Your response must be concise. -5.93. In the year 2005, what is the difference between the CO2 emissions (% of total fuel combustion) of Mexico and CO2 emissions (% of total fuel combustion) of Zambia?
Your answer should be very brief. -0.43. In the year 2005, what is the difference between the CO2 emissions (% of total fuel combustion) of Namibia and CO2 emissions (% of total fuel combustion) of Vietnam?
Your response must be concise. -11.77. In the year 2005, what is the difference between the CO2 emissions (% of total fuel combustion) in Namibia and CO2 emissions (% of total fuel combustion) in Zambia?
Keep it short and to the point. -6.27. In the year 2005, what is the difference between the CO2 emissions (% of total fuel combustion) of Vietnam and CO2 emissions (% of total fuel combustion) of Zambia?
Your answer should be compact. 5.5. In the year 2006, what is the difference between the CO2 emissions (% of total fuel combustion) of Mexico and CO2 emissions (% of total fuel combustion) of Namibia?
Provide a short and direct response. 5.81. In the year 2006, what is the difference between the CO2 emissions (% of total fuel combustion) in Mexico and CO2 emissions (% of total fuel combustion) in Vietnam?
Your answer should be compact. -5.51. In the year 2006, what is the difference between the CO2 emissions (% of total fuel combustion) of Mexico and CO2 emissions (% of total fuel combustion) of Zambia?
Ensure brevity in your answer.  3.73. In the year 2006, what is the difference between the CO2 emissions (% of total fuel combustion) in Namibia and CO2 emissions (% of total fuel combustion) in Vietnam?
Provide a short and direct response. -11.32. In the year 2006, what is the difference between the CO2 emissions (% of total fuel combustion) in Namibia and CO2 emissions (% of total fuel combustion) in Zambia?
Provide a succinct answer. -2.09. In the year 2006, what is the difference between the CO2 emissions (% of total fuel combustion) in Vietnam and CO2 emissions (% of total fuel combustion) in Zambia?
Offer a terse response. 9.24. In the year 2007, what is the difference between the CO2 emissions (% of total fuel combustion) of Mexico and CO2 emissions (% of total fuel combustion) of Namibia?
Your response must be concise. 5.49. In the year 2007, what is the difference between the CO2 emissions (% of total fuel combustion) in Mexico and CO2 emissions (% of total fuel combustion) in Vietnam?
Offer a terse response. -4.83. In the year 2007, what is the difference between the CO2 emissions (% of total fuel combustion) in Mexico and CO2 emissions (% of total fuel combustion) in Zambia?
Provide a short and direct response. 3.08. In the year 2007, what is the difference between the CO2 emissions (% of total fuel combustion) of Namibia and CO2 emissions (% of total fuel combustion) of Vietnam?
Make the answer very short. -10.32. In the year 2007, what is the difference between the CO2 emissions (% of total fuel combustion) in Namibia and CO2 emissions (% of total fuel combustion) in Zambia?
Provide a succinct answer. -2.41. In the year 2007, what is the difference between the CO2 emissions (% of total fuel combustion) of Vietnam and CO2 emissions (% of total fuel combustion) of Zambia?
Offer a terse response. 7.91. In the year 2008, what is the difference between the CO2 emissions (% of total fuel combustion) of Mexico and CO2 emissions (% of total fuel combustion) of Namibia?
Give a very brief answer. 5.52. In the year 2008, what is the difference between the CO2 emissions (% of total fuel combustion) in Mexico and CO2 emissions (% of total fuel combustion) in Vietnam?
Ensure brevity in your answer.  -3.74. In the year 2008, what is the difference between the CO2 emissions (% of total fuel combustion) of Mexico and CO2 emissions (% of total fuel combustion) of Zambia?
Offer a terse response. 2.78. In the year 2008, what is the difference between the CO2 emissions (% of total fuel combustion) in Namibia and CO2 emissions (% of total fuel combustion) in Vietnam?
Provide a short and direct response. -9.26. In the year 2008, what is the difference between the CO2 emissions (% of total fuel combustion) of Namibia and CO2 emissions (% of total fuel combustion) of Zambia?
Your answer should be compact. -2.75. In the year 2008, what is the difference between the CO2 emissions (% of total fuel combustion) of Vietnam and CO2 emissions (% of total fuel combustion) of Zambia?
Offer a terse response. 6.52. In the year 2009, what is the difference between the CO2 emissions (% of total fuel combustion) of Mexico and CO2 emissions (% of total fuel combustion) of Namibia?
Offer a very short reply. 5.35. In the year 2009, what is the difference between the CO2 emissions (% of total fuel combustion) of Mexico and CO2 emissions (% of total fuel combustion) of Vietnam?
Give a very brief answer. -3.03. In the year 2009, what is the difference between the CO2 emissions (% of total fuel combustion) in Mexico and CO2 emissions (% of total fuel combustion) in Zambia?
Offer a very short reply. 2.72. In the year 2009, what is the difference between the CO2 emissions (% of total fuel combustion) of Namibia and CO2 emissions (% of total fuel combustion) of Vietnam?
Offer a very short reply. -8.38. In the year 2009, what is the difference between the CO2 emissions (% of total fuel combustion) in Namibia and CO2 emissions (% of total fuel combustion) in Zambia?
Your answer should be compact. -2.63. In the year 2009, what is the difference between the CO2 emissions (% of total fuel combustion) of Vietnam and CO2 emissions (% of total fuel combustion) of Zambia?
Provide a short and direct response. 5.75. In the year 2010, what is the difference between the CO2 emissions (% of total fuel combustion) in Mexico and CO2 emissions (% of total fuel combustion) in Namibia?
Give a very brief answer. 5.28. In the year 2010, what is the difference between the CO2 emissions (% of total fuel combustion) of Mexico and CO2 emissions (% of total fuel combustion) of Vietnam?
Your response must be concise. -2.65. In the year 2010, what is the difference between the CO2 emissions (% of total fuel combustion) in Mexico and CO2 emissions (% of total fuel combustion) in Zambia?
Your response must be concise. 2.19. In the year 2010, what is the difference between the CO2 emissions (% of total fuel combustion) in Namibia and CO2 emissions (% of total fuel combustion) in Vietnam?
Your answer should be very brief. -7.93. In the year 2010, what is the difference between the CO2 emissions (% of total fuel combustion) in Namibia and CO2 emissions (% of total fuel combustion) in Zambia?
Provide a succinct answer. -3.09. In the year 2010, what is the difference between the CO2 emissions (% of total fuel combustion) of Vietnam and CO2 emissions (% of total fuel combustion) of Zambia?
Your response must be concise. 4.84. What is the ratio of the CO2 emissions (% of total fuel combustion) in Mexico in 2004 to that in 2005?
Provide a succinct answer. 1.1. What is the ratio of the CO2 emissions (% of total fuel combustion) of Namibia in 2004 to that in 2005?
Your answer should be very brief. 1. What is the ratio of the CO2 emissions (% of total fuel combustion) in Vietnam in 2004 to that in 2005?
Offer a terse response. 1.04. What is the ratio of the CO2 emissions (% of total fuel combustion) of Zambia in 2004 to that in 2005?
Ensure brevity in your answer.  1.07. What is the ratio of the CO2 emissions (% of total fuel combustion) in Mexico in 2004 to that in 2006?
Your answer should be very brief. 1.1. What is the ratio of the CO2 emissions (% of total fuel combustion) in Namibia in 2004 to that in 2006?
Offer a terse response. 1.01. What is the ratio of the CO2 emissions (% of total fuel combustion) in Vietnam in 2004 to that in 2006?
Your answer should be compact. 1.08. What is the ratio of the CO2 emissions (% of total fuel combustion) of Zambia in 2004 to that in 2006?
Your response must be concise. 2.86. What is the ratio of the CO2 emissions (% of total fuel combustion) of Mexico in 2004 to that in 2007?
Your answer should be very brief. 1.17. What is the ratio of the CO2 emissions (% of total fuel combustion) of Namibia in 2004 to that in 2007?
Make the answer very short. 1.04. What is the ratio of the CO2 emissions (% of total fuel combustion) of Vietnam in 2004 to that in 2007?
Offer a very short reply. 1.19. What is the ratio of the CO2 emissions (% of total fuel combustion) of Zambia in 2004 to that in 2007?
Offer a very short reply. 2.55. What is the ratio of the CO2 emissions (% of total fuel combustion) in Mexico in 2004 to that in 2008?
Your answer should be compact. 1.17. What is the ratio of the CO2 emissions (% of total fuel combustion) of Namibia in 2004 to that in 2008?
Your answer should be very brief. 1.2. What is the ratio of the CO2 emissions (% of total fuel combustion) of Vietnam in 2004 to that in 2008?
Make the answer very short. 1.32. What is the ratio of the CO2 emissions (% of total fuel combustion) in Zambia in 2004 to that in 2008?
Your answer should be very brief. 2.31. What is the ratio of the CO2 emissions (% of total fuel combustion) of Mexico in 2004 to that in 2009?
Your answer should be very brief. 1.21. What is the ratio of the CO2 emissions (% of total fuel combustion) in Namibia in 2004 to that in 2009?
Ensure brevity in your answer.  1.23. What is the ratio of the CO2 emissions (% of total fuel combustion) in Vietnam in 2004 to that in 2009?
Provide a short and direct response. 1.46. What is the ratio of the CO2 emissions (% of total fuel combustion) in Zambia in 2004 to that in 2009?
Your response must be concise. 2.41. What is the ratio of the CO2 emissions (% of total fuel combustion) of Mexico in 2004 to that in 2010?
Your answer should be compact. 1.23. What is the ratio of the CO2 emissions (% of total fuel combustion) of Namibia in 2004 to that in 2010?
Ensure brevity in your answer.  1.28. What is the ratio of the CO2 emissions (% of total fuel combustion) in Vietnam in 2004 to that in 2010?
Offer a terse response. 1.54. What is the ratio of the CO2 emissions (% of total fuel combustion) of Zambia in 2004 to that in 2010?
Make the answer very short. 2.09. What is the ratio of the CO2 emissions (% of total fuel combustion) in Namibia in 2005 to that in 2006?
Make the answer very short. 1.01. What is the ratio of the CO2 emissions (% of total fuel combustion) in Vietnam in 2005 to that in 2006?
Offer a terse response. 1.04. What is the ratio of the CO2 emissions (% of total fuel combustion) in Zambia in 2005 to that in 2006?
Ensure brevity in your answer.  2.67. What is the ratio of the CO2 emissions (% of total fuel combustion) in Mexico in 2005 to that in 2007?
Offer a very short reply. 1.06. What is the ratio of the CO2 emissions (% of total fuel combustion) of Namibia in 2005 to that in 2007?
Your answer should be compact. 1.04. What is the ratio of the CO2 emissions (% of total fuel combustion) in Vietnam in 2005 to that in 2007?
Your response must be concise. 1.14. What is the ratio of the CO2 emissions (% of total fuel combustion) of Zambia in 2005 to that in 2007?
Ensure brevity in your answer.  2.38. What is the ratio of the CO2 emissions (% of total fuel combustion) of Mexico in 2005 to that in 2008?
Ensure brevity in your answer.  1.07. What is the ratio of the CO2 emissions (% of total fuel combustion) in Namibia in 2005 to that in 2008?
Keep it short and to the point. 1.2. What is the ratio of the CO2 emissions (% of total fuel combustion) of Vietnam in 2005 to that in 2008?
Your response must be concise. 1.27. What is the ratio of the CO2 emissions (% of total fuel combustion) in Zambia in 2005 to that in 2008?
Keep it short and to the point. 2.16. What is the ratio of the CO2 emissions (% of total fuel combustion) in Mexico in 2005 to that in 2009?
Your answer should be very brief. 1.1. What is the ratio of the CO2 emissions (% of total fuel combustion) in Namibia in 2005 to that in 2009?
Offer a terse response. 1.23. What is the ratio of the CO2 emissions (% of total fuel combustion) of Vietnam in 2005 to that in 2009?
Provide a short and direct response. 1.4. What is the ratio of the CO2 emissions (% of total fuel combustion) of Zambia in 2005 to that in 2009?
Provide a short and direct response. 2.25. What is the ratio of the CO2 emissions (% of total fuel combustion) of Mexico in 2005 to that in 2010?
Your answer should be compact. 1.12. What is the ratio of the CO2 emissions (% of total fuel combustion) in Namibia in 2005 to that in 2010?
Your answer should be compact. 1.28. What is the ratio of the CO2 emissions (% of total fuel combustion) of Vietnam in 2005 to that in 2010?
Your answer should be compact. 1.48. What is the ratio of the CO2 emissions (% of total fuel combustion) in Zambia in 2005 to that in 2010?
Offer a very short reply. 1.95. What is the ratio of the CO2 emissions (% of total fuel combustion) of Mexico in 2006 to that in 2007?
Your response must be concise. 1.06. What is the ratio of the CO2 emissions (% of total fuel combustion) in Namibia in 2006 to that in 2007?
Give a very brief answer. 1.03. What is the ratio of the CO2 emissions (% of total fuel combustion) in Vietnam in 2006 to that in 2007?
Give a very brief answer. 1.09. What is the ratio of the CO2 emissions (% of total fuel combustion) of Zambia in 2006 to that in 2007?
Your answer should be compact. 0.89. What is the ratio of the CO2 emissions (% of total fuel combustion) of Mexico in 2006 to that in 2008?
Ensure brevity in your answer.  1.06. What is the ratio of the CO2 emissions (% of total fuel combustion) in Namibia in 2006 to that in 2008?
Your answer should be very brief. 1.19. What is the ratio of the CO2 emissions (% of total fuel combustion) in Vietnam in 2006 to that in 2008?
Provide a short and direct response. 1.22. What is the ratio of the CO2 emissions (% of total fuel combustion) in Zambia in 2006 to that in 2008?
Offer a terse response. 0.81. What is the ratio of the CO2 emissions (% of total fuel combustion) of Mexico in 2006 to that in 2009?
Keep it short and to the point. 1.09. What is the ratio of the CO2 emissions (% of total fuel combustion) in Namibia in 2006 to that in 2009?
Your response must be concise. 1.22. What is the ratio of the CO2 emissions (% of total fuel combustion) in Vietnam in 2006 to that in 2009?
Provide a short and direct response. 1.35. What is the ratio of the CO2 emissions (% of total fuel combustion) of Zambia in 2006 to that in 2009?
Your response must be concise. 0.84. What is the ratio of the CO2 emissions (% of total fuel combustion) in Mexico in 2006 to that in 2010?
Your answer should be very brief. 1.11. What is the ratio of the CO2 emissions (% of total fuel combustion) of Namibia in 2006 to that in 2010?
Offer a very short reply. 1.27. What is the ratio of the CO2 emissions (% of total fuel combustion) of Vietnam in 2006 to that in 2010?
Make the answer very short. 1.42. What is the ratio of the CO2 emissions (% of total fuel combustion) in Zambia in 2006 to that in 2010?
Give a very brief answer. 0.73. What is the ratio of the CO2 emissions (% of total fuel combustion) of Namibia in 2007 to that in 2008?
Offer a terse response. 1.15. What is the ratio of the CO2 emissions (% of total fuel combustion) in Vietnam in 2007 to that in 2008?
Your answer should be compact. 1.12. What is the ratio of the CO2 emissions (% of total fuel combustion) of Zambia in 2007 to that in 2008?
Ensure brevity in your answer.  0.91. What is the ratio of the CO2 emissions (% of total fuel combustion) in Mexico in 2007 to that in 2009?
Offer a terse response. 1.04. What is the ratio of the CO2 emissions (% of total fuel combustion) of Namibia in 2007 to that in 2009?
Keep it short and to the point. 1.18. What is the ratio of the CO2 emissions (% of total fuel combustion) of Vietnam in 2007 to that in 2009?
Your answer should be very brief. 1.23. What is the ratio of the CO2 emissions (% of total fuel combustion) in Zambia in 2007 to that in 2009?
Keep it short and to the point. 0.95. What is the ratio of the CO2 emissions (% of total fuel combustion) of Mexico in 2007 to that in 2010?
Your answer should be very brief. 1.05. What is the ratio of the CO2 emissions (% of total fuel combustion) in Namibia in 2007 to that in 2010?
Provide a short and direct response. 1.23. What is the ratio of the CO2 emissions (% of total fuel combustion) in Vietnam in 2007 to that in 2010?
Provide a succinct answer. 1.3. What is the ratio of the CO2 emissions (% of total fuel combustion) in Zambia in 2007 to that in 2010?
Make the answer very short. 0.82. What is the ratio of the CO2 emissions (% of total fuel combustion) in Mexico in 2008 to that in 2009?
Make the answer very short. 1.03. What is the ratio of the CO2 emissions (% of total fuel combustion) in Namibia in 2008 to that in 2009?
Your answer should be very brief. 1.03. What is the ratio of the CO2 emissions (% of total fuel combustion) in Vietnam in 2008 to that in 2009?
Offer a terse response. 1.1. What is the ratio of the CO2 emissions (% of total fuel combustion) of Zambia in 2008 to that in 2009?
Offer a terse response. 1.04. What is the ratio of the CO2 emissions (% of total fuel combustion) of Mexico in 2008 to that in 2010?
Provide a succinct answer. 1.05. What is the ratio of the CO2 emissions (% of total fuel combustion) of Namibia in 2008 to that in 2010?
Your response must be concise. 1.07. What is the ratio of the CO2 emissions (% of total fuel combustion) in Vietnam in 2008 to that in 2010?
Keep it short and to the point. 1.16. What is the ratio of the CO2 emissions (% of total fuel combustion) in Zambia in 2008 to that in 2010?
Your answer should be very brief. 0.91. What is the ratio of the CO2 emissions (% of total fuel combustion) in Mexico in 2009 to that in 2010?
Ensure brevity in your answer.  1.02. What is the ratio of the CO2 emissions (% of total fuel combustion) of Namibia in 2009 to that in 2010?
Provide a short and direct response. 1.05. What is the ratio of the CO2 emissions (% of total fuel combustion) of Vietnam in 2009 to that in 2010?
Your answer should be compact. 1.06. What is the ratio of the CO2 emissions (% of total fuel combustion) of Zambia in 2009 to that in 2010?
Provide a succinct answer. 0.87. What is the difference between the highest and the second highest CO2 emissions (% of total fuel combustion) of Mexico?
Provide a succinct answer. 0.62. What is the difference between the highest and the second highest CO2 emissions (% of total fuel combustion) in Vietnam?
Give a very brief answer. 0.53. What is the difference between the highest and the second highest CO2 emissions (% of total fuel combustion) in Zambia?
Provide a succinct answer. 0.48. What is the difference between the highest and the lowest CO2 emissions (% of total fuel combustion) of Mexico?
Ensure brevity in your answer.  1.27. What is the difference between the highest and the lowest CO2 emissions (% of total fuel combustion) in Namibia?
Offer a terse response. 0.09. What is the difference between the highest and the lowest CO2 emissions (% of total fuel combustion) in Vietnam?
Make the answer very short. 4.46. What is the difference between the highest and the lowest CO2 emissions (% of total fuel combustion) in Zambia?
Ensure brevity in your answer.  4.67. 